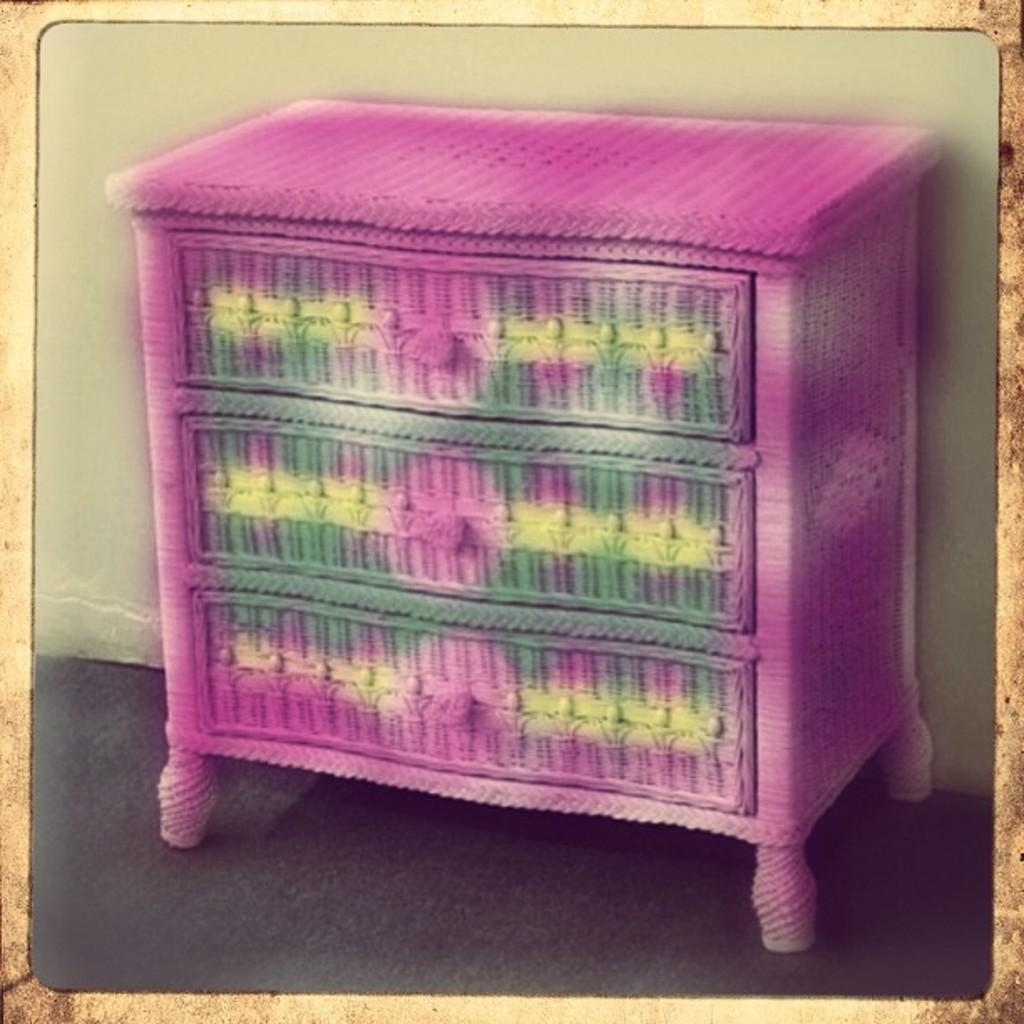What type of furniture is present in the image? There is a table in the image. Can you describe the appearance of the table? The table has different colors. What feature is present on the table? There are drawers on the table. What can be seen in the background of the image? There is a wall visible in the image. Where is the map of downtown located in the image? There is no map or downtown mentioned in the image; it only features a table with drawers and a wall in the background. 